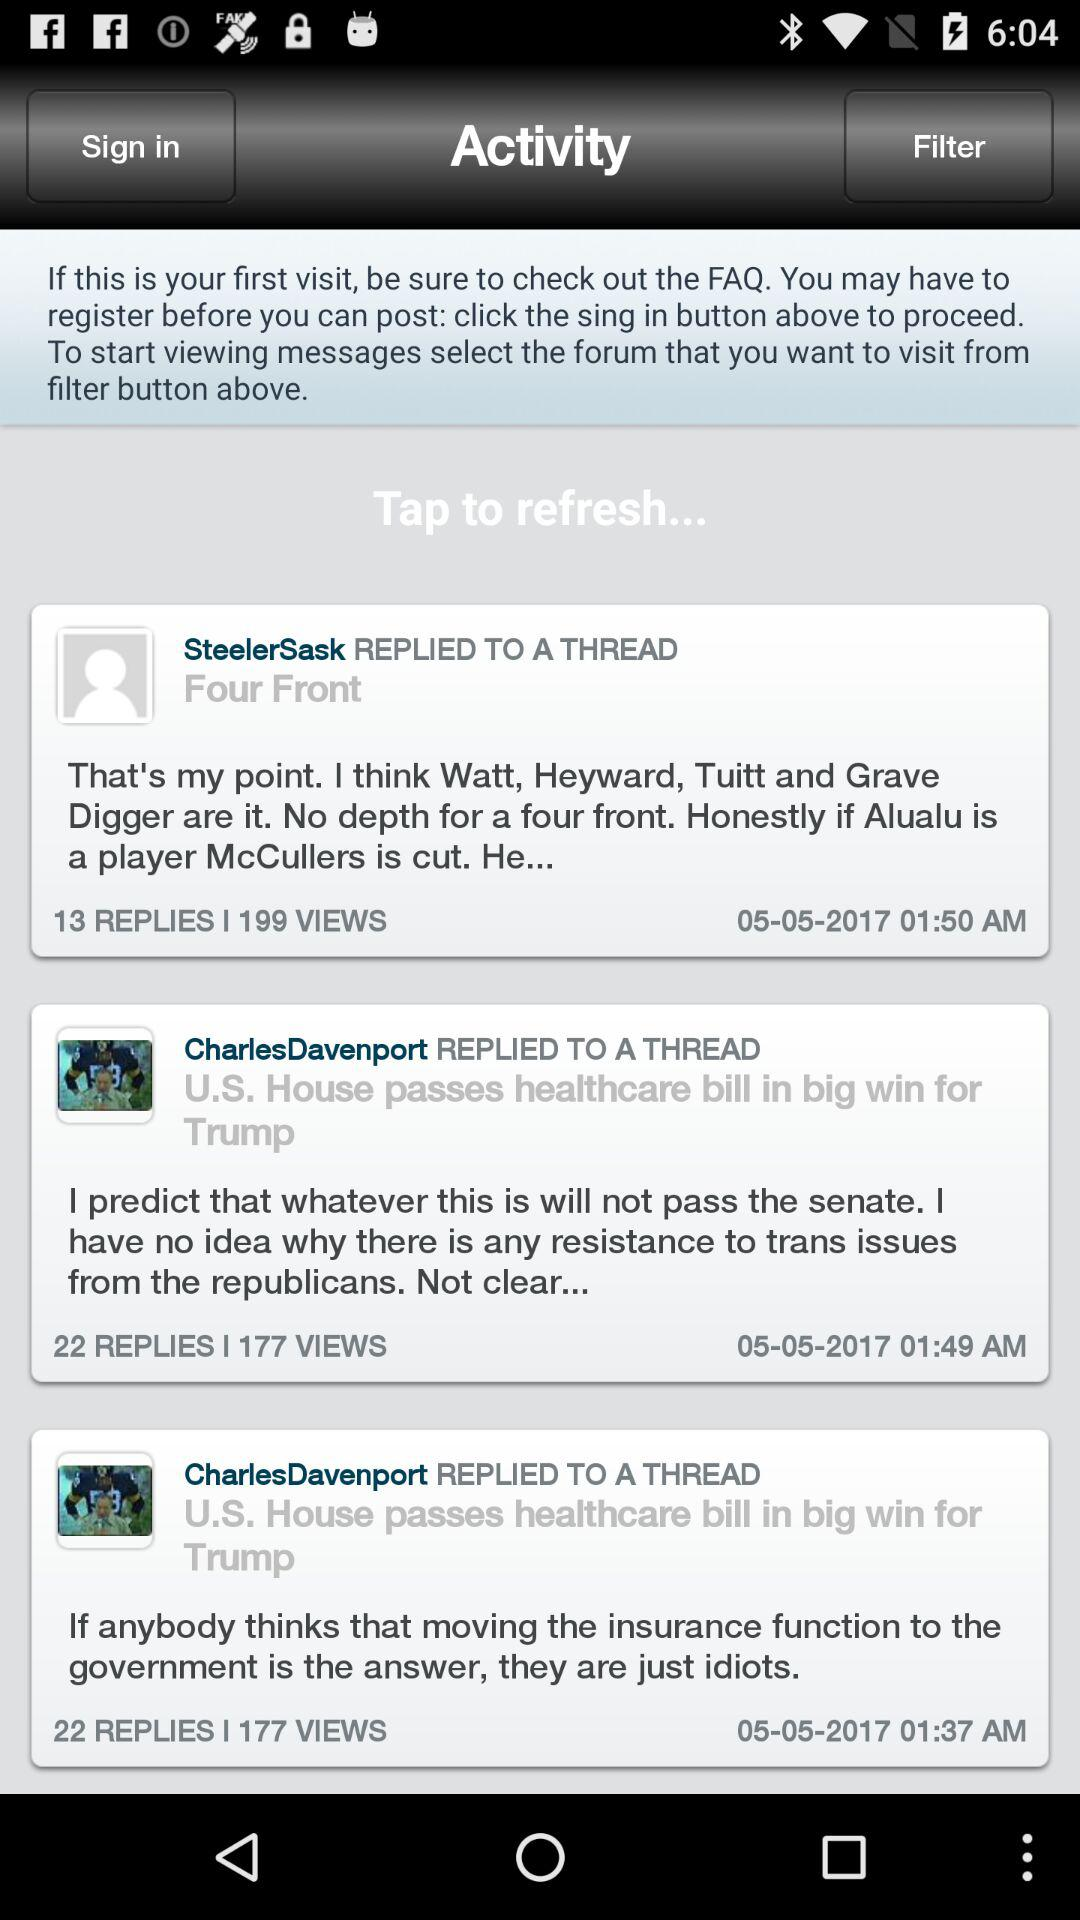What is the date when Steelersask commented? The date is May 05, 2017. 